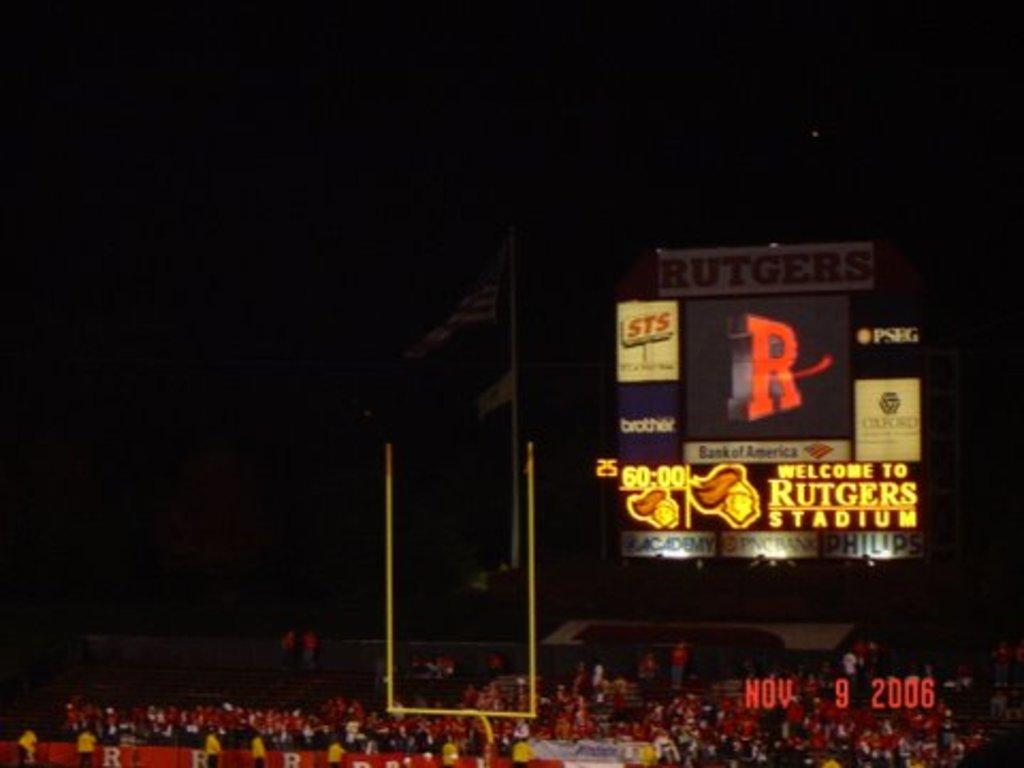<image>
Summarize the visual content of the image. The signboard at the football field says Welcome to Rutgers Stadium. 